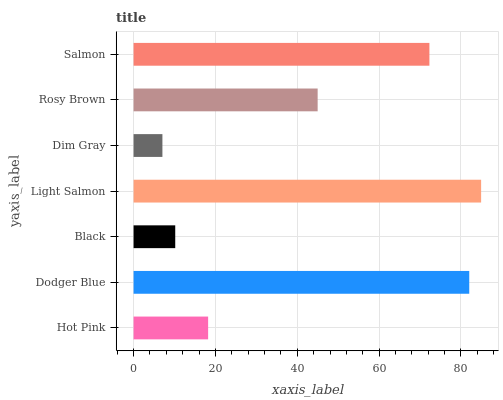Is Dim Gray the minimum?
Answer yes or no. Yes. Is Light Salmon the maximum?
Answer yes or no. Yes. Is Dodger Blue the minimum?
Answer yes or no. No. Is Dodger Blue the maximum?
Answer yes or no. No. Is Dodger Blue greater than Hot Pink?
Answer yes or no. Yes. Is Hot Pink less than Dodger Blue?
Answer yes or no. Yes. Is Hot Pink greater than Dodger Blue?
Answer yes or no. No. Is Dodger Blue less than Hot Pink?
Answer yes or no. No. Is Rosy Brown the high median?
Answer yes or no. Yes. Is Rosy Brown the low median?
Answer yes or no. Yes. Is Salmon the high median?
Answer yes or no. No. Is Black the low median?
Answer yes or no. No. 